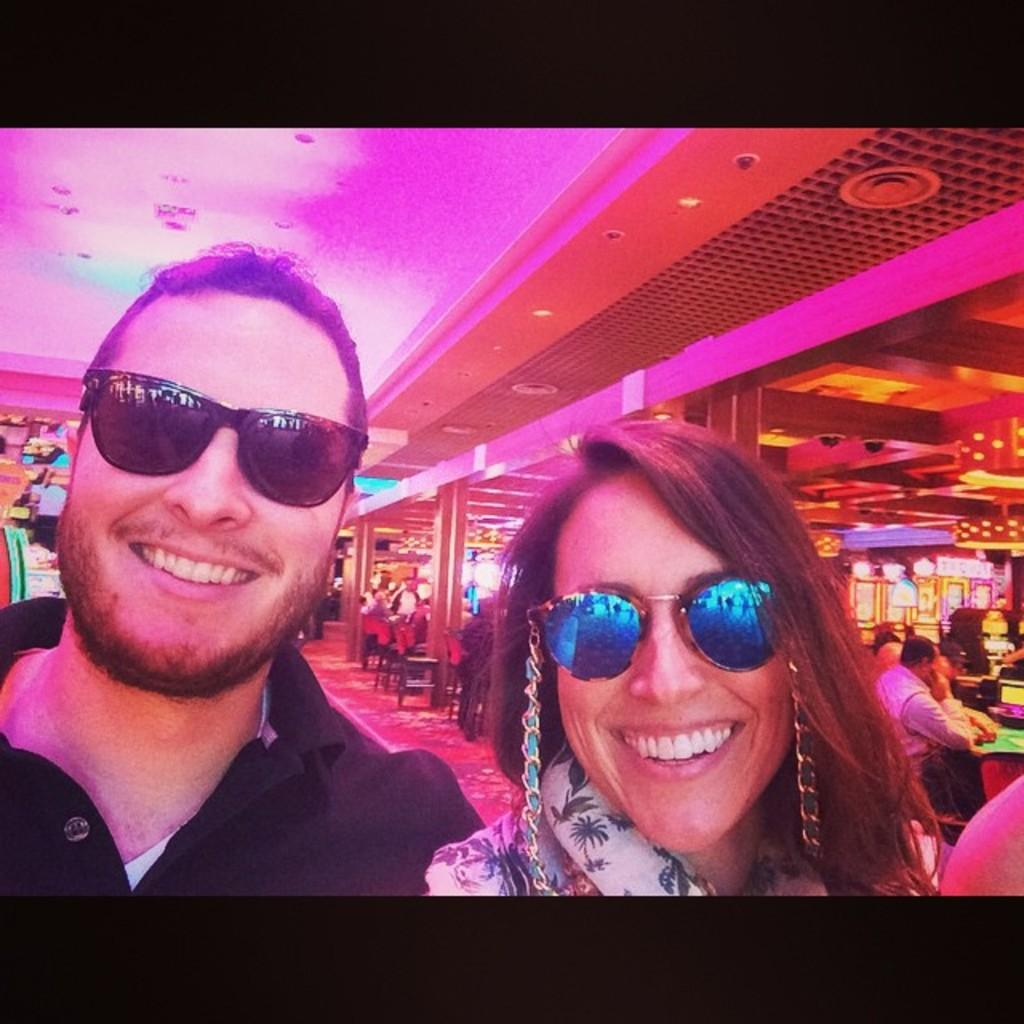What is the man in the image wearing? The man is wearing goggles in the image. What is the man's facial expression? The man is smiling in the image. What is the woman in the image wearing? The woman is wearing goggles in the image. What is the woman's facial expression? The woman is smiling in the image. What can be seen in the background of the image? There are chairs, pillars, lights, and other persons in the background of the image. What type of bell can be heard ringing in the image? There is no bell present in the image, and therefore no sound can be heard. What kind of popcorn is being served to the dolls in the image? There are no dolls or popcorn present in the image. 